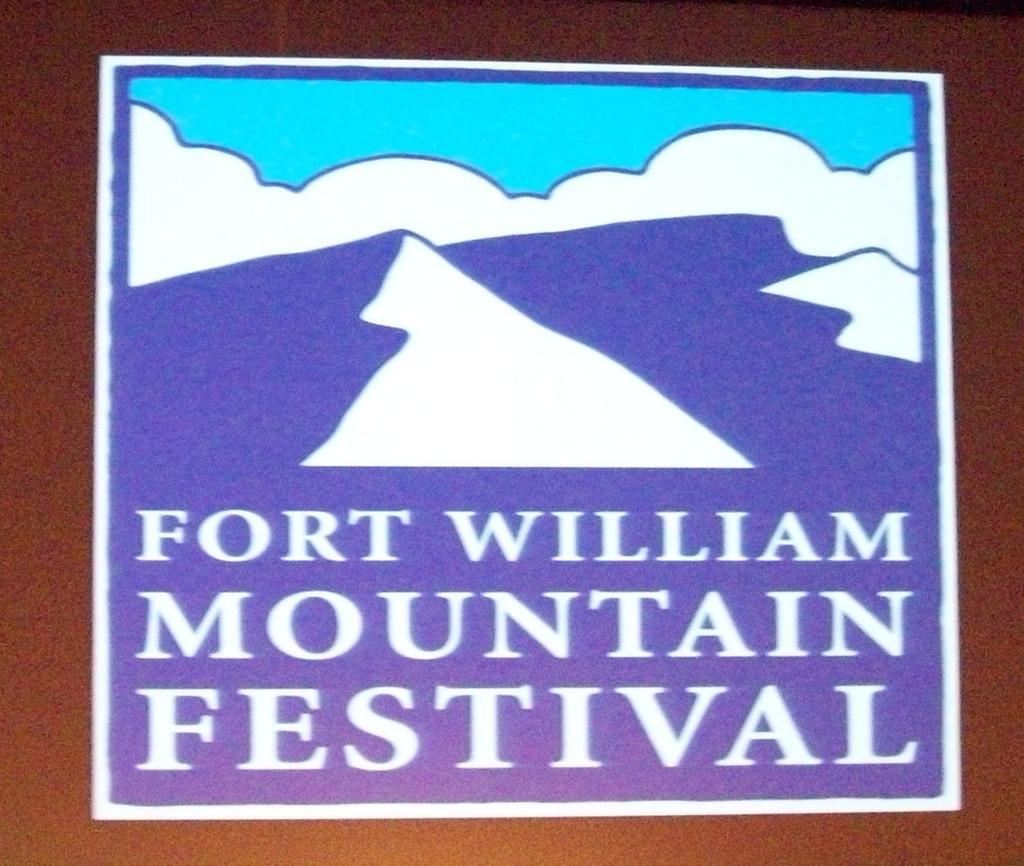<image>
Write a terse but informative summary of the picture. A sticker for Fort William Mountain Festival with a picture of a mountain. 